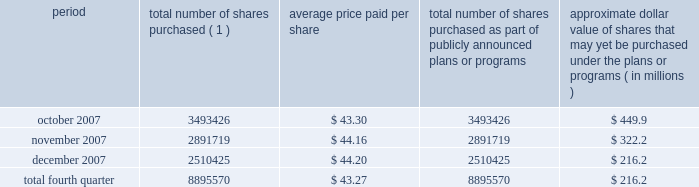Issuer purchases of equity securities during the three months ended december 31 , 2007 , we repurchased 8895570 shares of our class a common stock for an aggregate of $ 385.1 million pursuant to the $ 1.5 billion stock repurchase program publicly announced in february 2007 , as follows : period total number of shares purchased ( 1 ) average price paid per share total number of shares purchased as part of publicly announced plans or programs approximate dollar value of shares that may yet be purchased under the plans or programs ( in millions ) .
( 1 ) issuer repurchases pursuant to the $ 1.5 billion stock repurchase program publicly announced in february 2007 .
Under this program , our management was authorized through february 2008 to purchase shares from time to time through open market purchases or privately negotiated transactions at prevailing prices as permitted by securities laws and other legal requirements , and subject to market conditions and other factors .
To facilitate repurchases , we typically made purchases pursuant to trading plans under rule 10b5-1 of the exchange act , which allow us to repurchase shares during periods when we otherwise might be prevented from doing so under insider trading laws or because of self-imposed trading blackout periods .
Subsequent to december 31 , 2007 , we repurchased 4.3 million shares of our class a common stock for an aggregate of $ 163.7 million pursuant to this program .
In february 2008 , our board of directors approved a new stock repurchase program , pursuant to which we are authorized to purchase up to an additional $ 1.5 billion of our class a common stock .
Purchases under this stock repurchase program are subject to us having available cash to fund repurchases , as further described in item 1a of this annual report under the caption 201crisk factors 2014we anticipate that we may need additional financing to fund our stock repurchase programs , to refinance our existing indebtedness and to fund future growth and expansion initiatives 201d and item 7 of this annual report under the caption 201cmanagement 2019s discussion and analysis of financial condition and results of operations 2014liquidity and capital resources . 201d .
During the 4th quarter of 2007 and the first quarter of 2008 , what were cumulative stock purchases in million dollars? 
Computations: (163.7 + 385.1)
Answer: 548.8. 